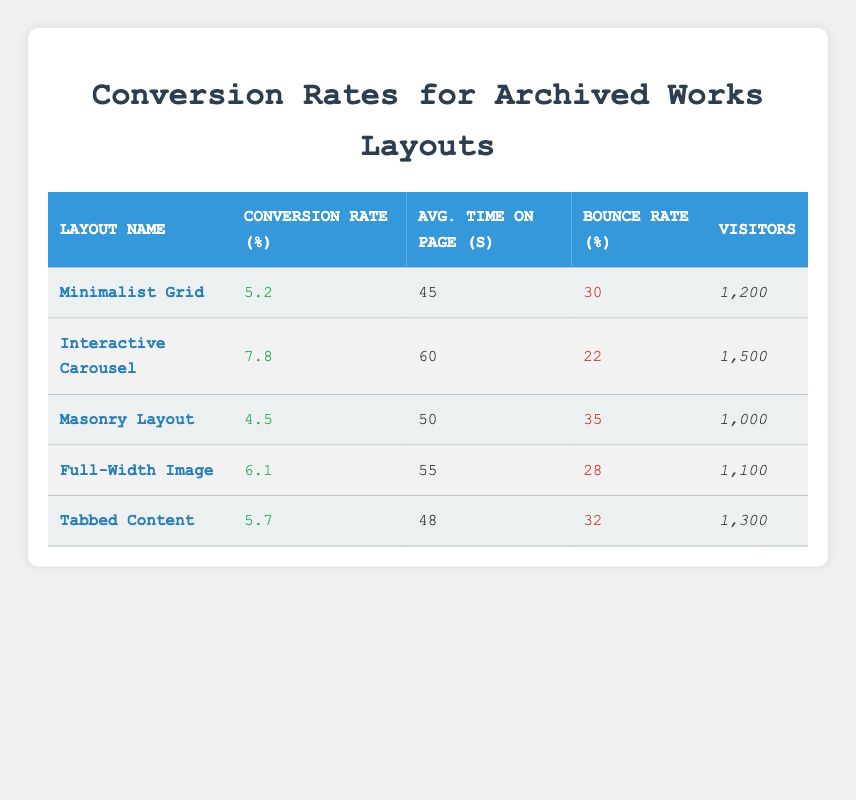What is the conversion rate for the Interactive Carousel layout? The table lists the conversion rate for the Interactive Carousel layout as 7.8%.
Answer: 7.8% Which design layout has the highest bounce rate? By examining the bounce rate column, the Masonry Layout has the highest bounce rate at 35%.
Answer: Masonry Layout What is the average time spent on the page for the Full-Width Image layout? The table shows that the average time spent on the page for the Full-Width Image layout is 55 seconds.
Answer: 55 seconds Calculate the average conversion rate across all design layouts. Adding the conversion rates: (5.2 + 7.8 + 4.5 + 6.1 + 5.7) gives a total of 29.3. There are 5 layouts, so the average is 29.3 / 5 = 5.86.
Answer: 5.86 True or False: The Tabbed Content layout has a lower conversion rate than the Minimalist Grid layout. The Tabbed Content layout has a conversion rate of 5.7% and the Minimalist Grid layout has a conversion rate of 5.2%. Since 5.7 is greater than 5.2, the statement is false.
Answer: False What is the total number of visitors across all design layouts? By summing the visitor numbers: 1200 + 1500 + 1000 + 1100 + 1300 equals 5100 visitors in total.
Answer: 5100 visitors Which layout has a conversion rate closest to the average conversion rate of all layouts? The average conversion rate is 5.86%, and comparing the layouts, the Tabbed Content with a rate of 5.7% is closest.
Answer: Tabbed Content What percentage of total visitors bounced on the Interactive Carousel layout? The bounce rate for the Interactive Carousel is 22%. To find the number of visitors that bounced: 1500 visitors * 0.22 gives 330. Thus, the percentage of total visitors who bounced is 22%.
Answer: 22% Which layout has the lowest average time on page and what is that time? The Minimalist Grid has the lowest average time on page at 45 seconds.
Answer: 45 seconds 